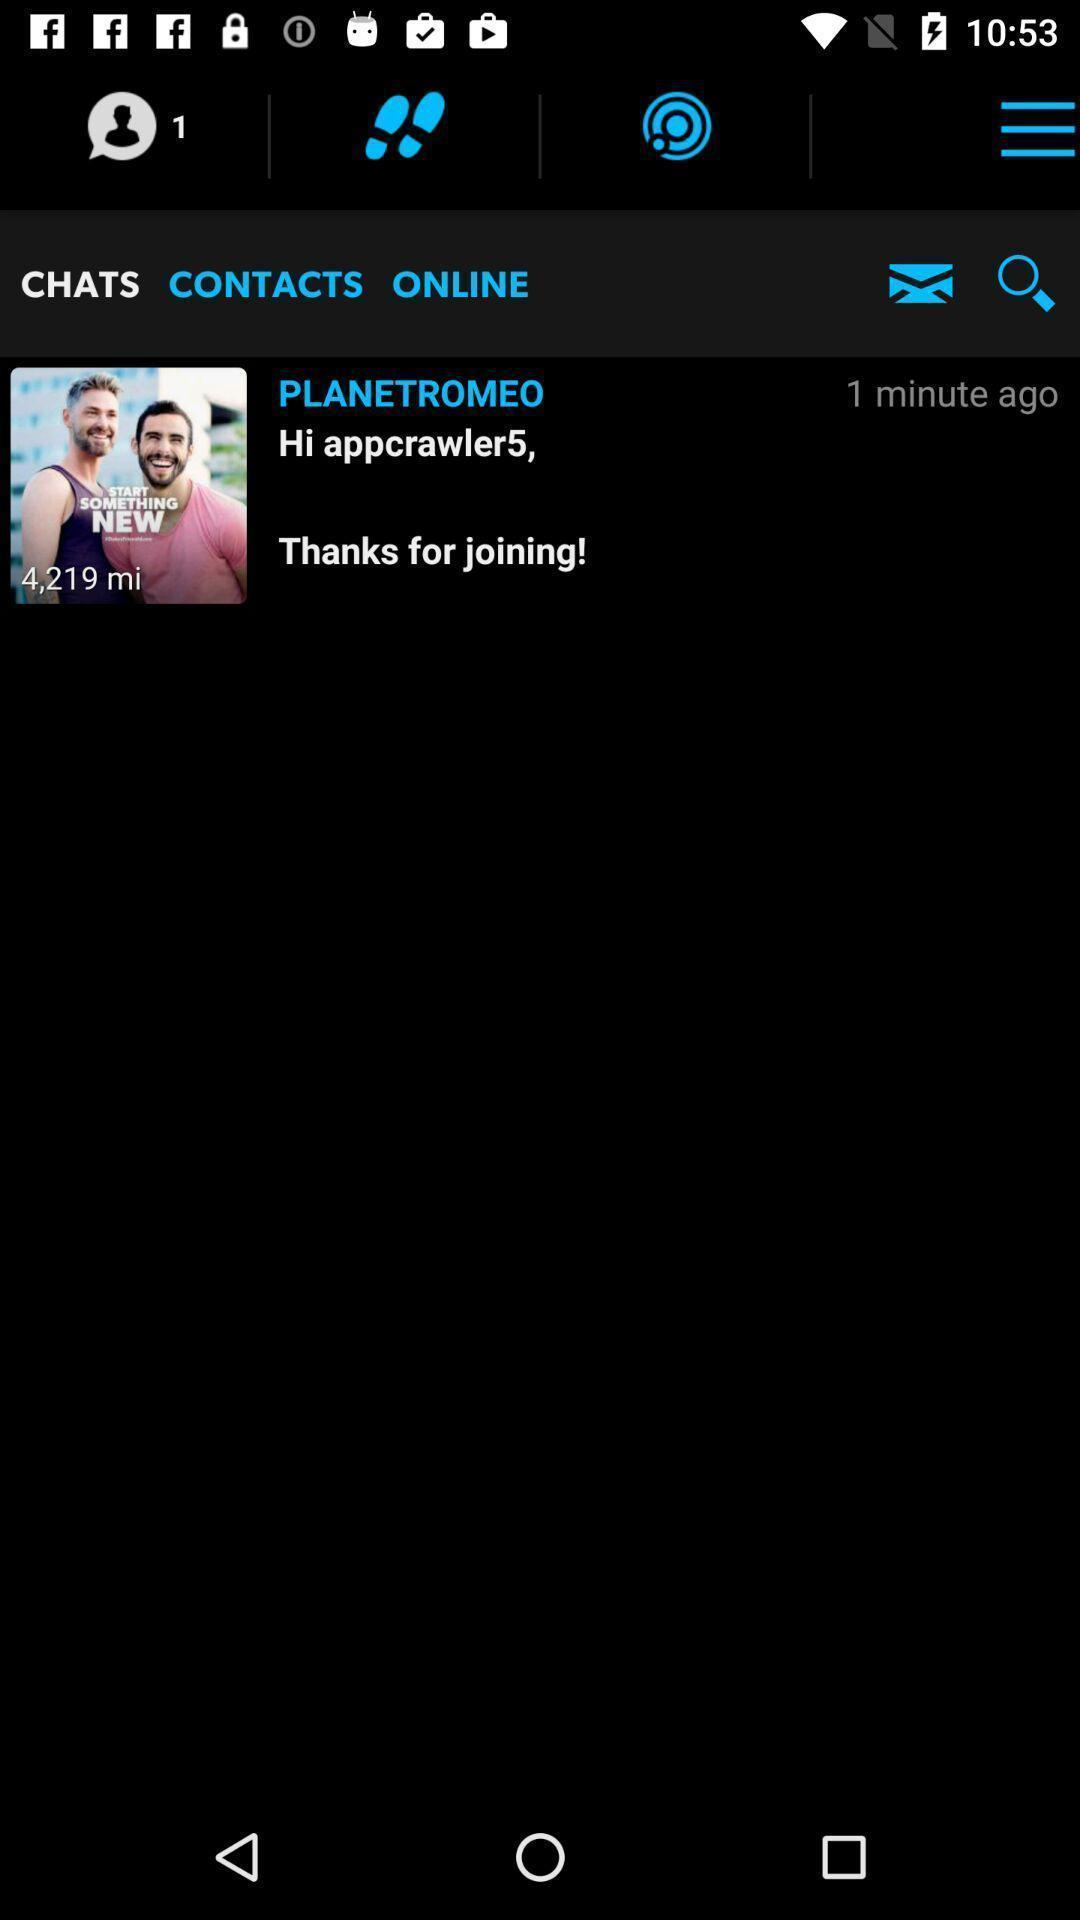Please provide a description for this image. Screen displaying the chats of app. 